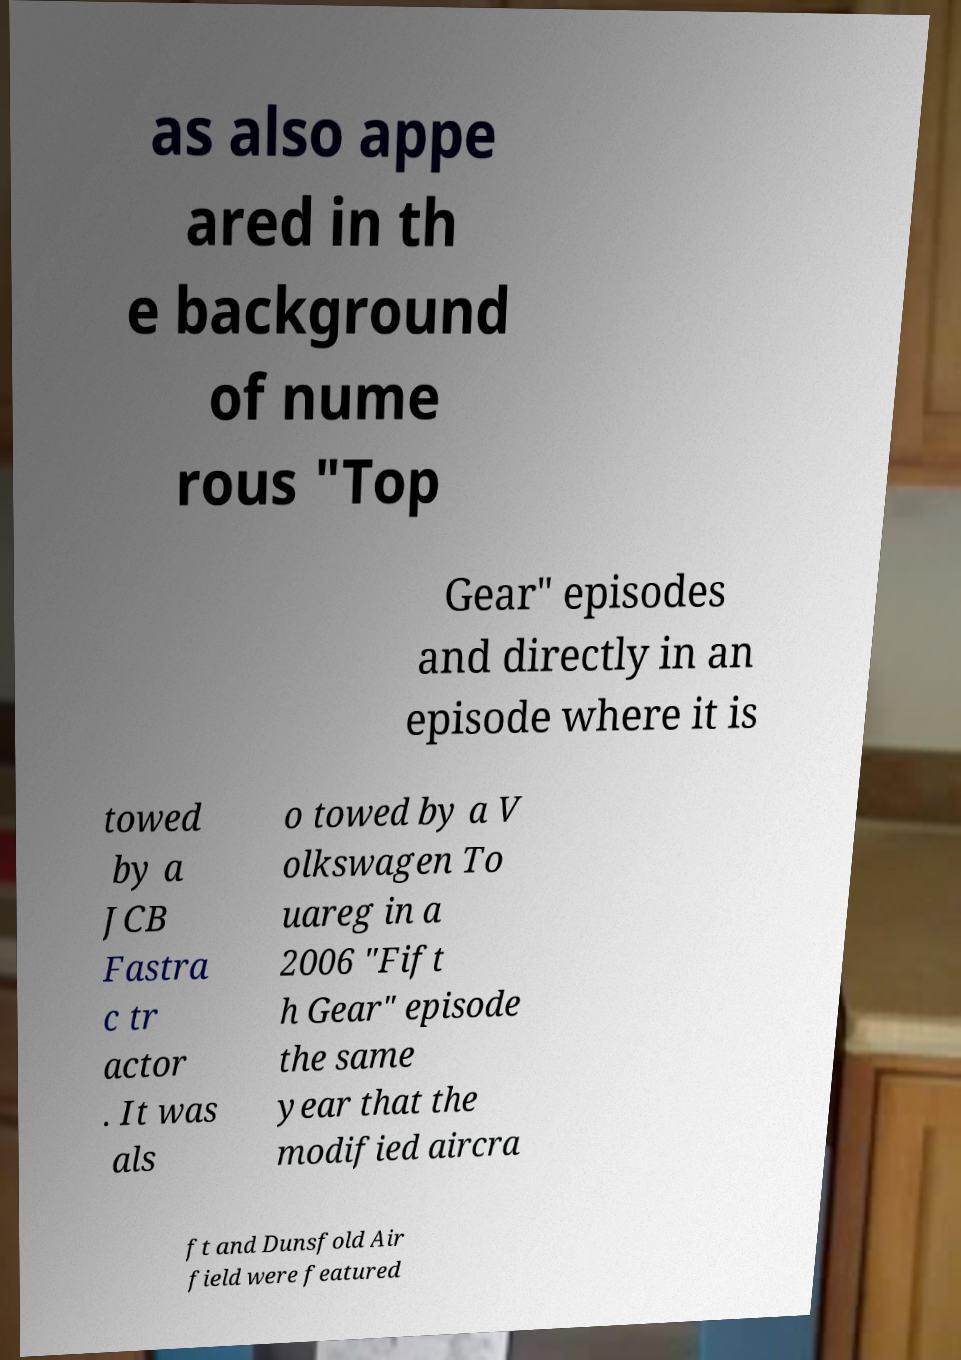Please identify and transcribe the text found in this image. as also appe ared in th e background of nume rous "Top Gear" episodes and directly in an episode where it is towed by a JCB Fastra c tr actor . It was als o towed by a V olkswagen To uareg in a 2006 "Fift h Gear" episode the same year that the modified aircra ft and Dunsfold Air field were featured 